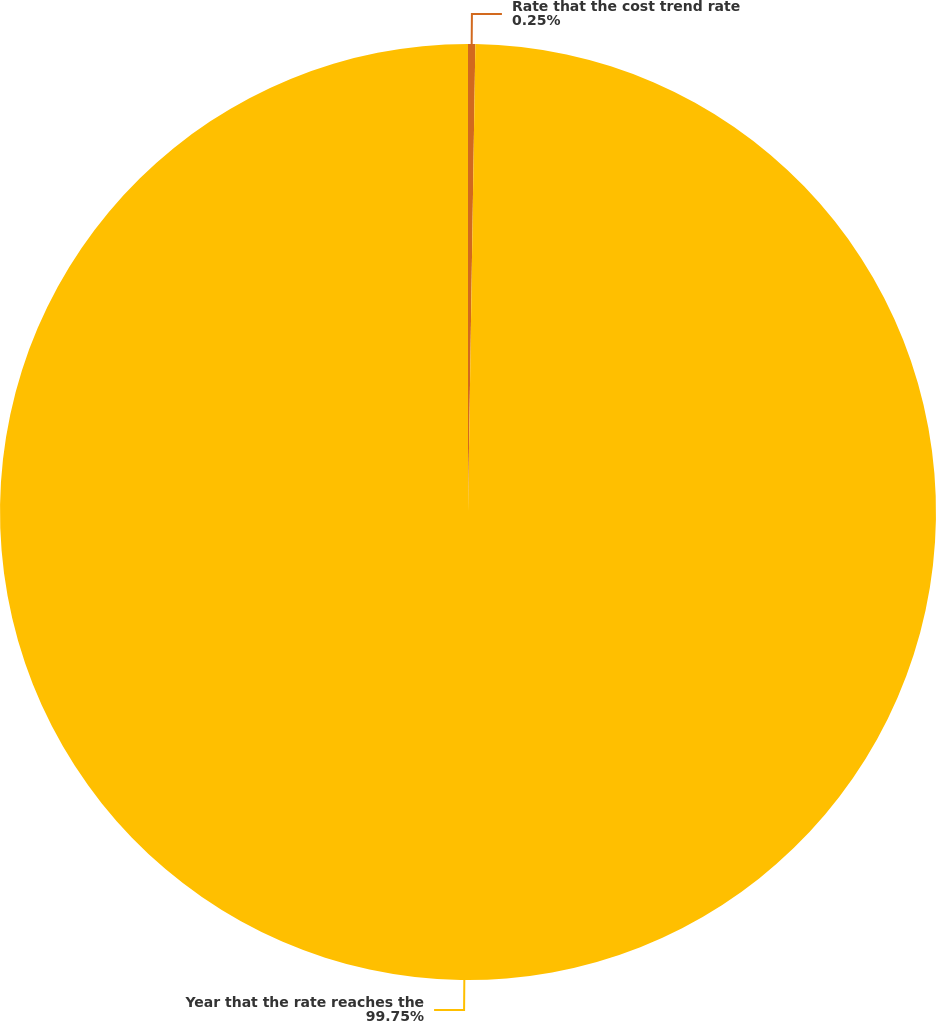Convert chart. <chart><loc_0><loc_0><loc_500><loc_500><pie_chart><fcel>Rate that the cost trend rate<fcel>Year that the rate reaches the<nl><fcel>0.25%<fcel>99.75%<nl></chart> 